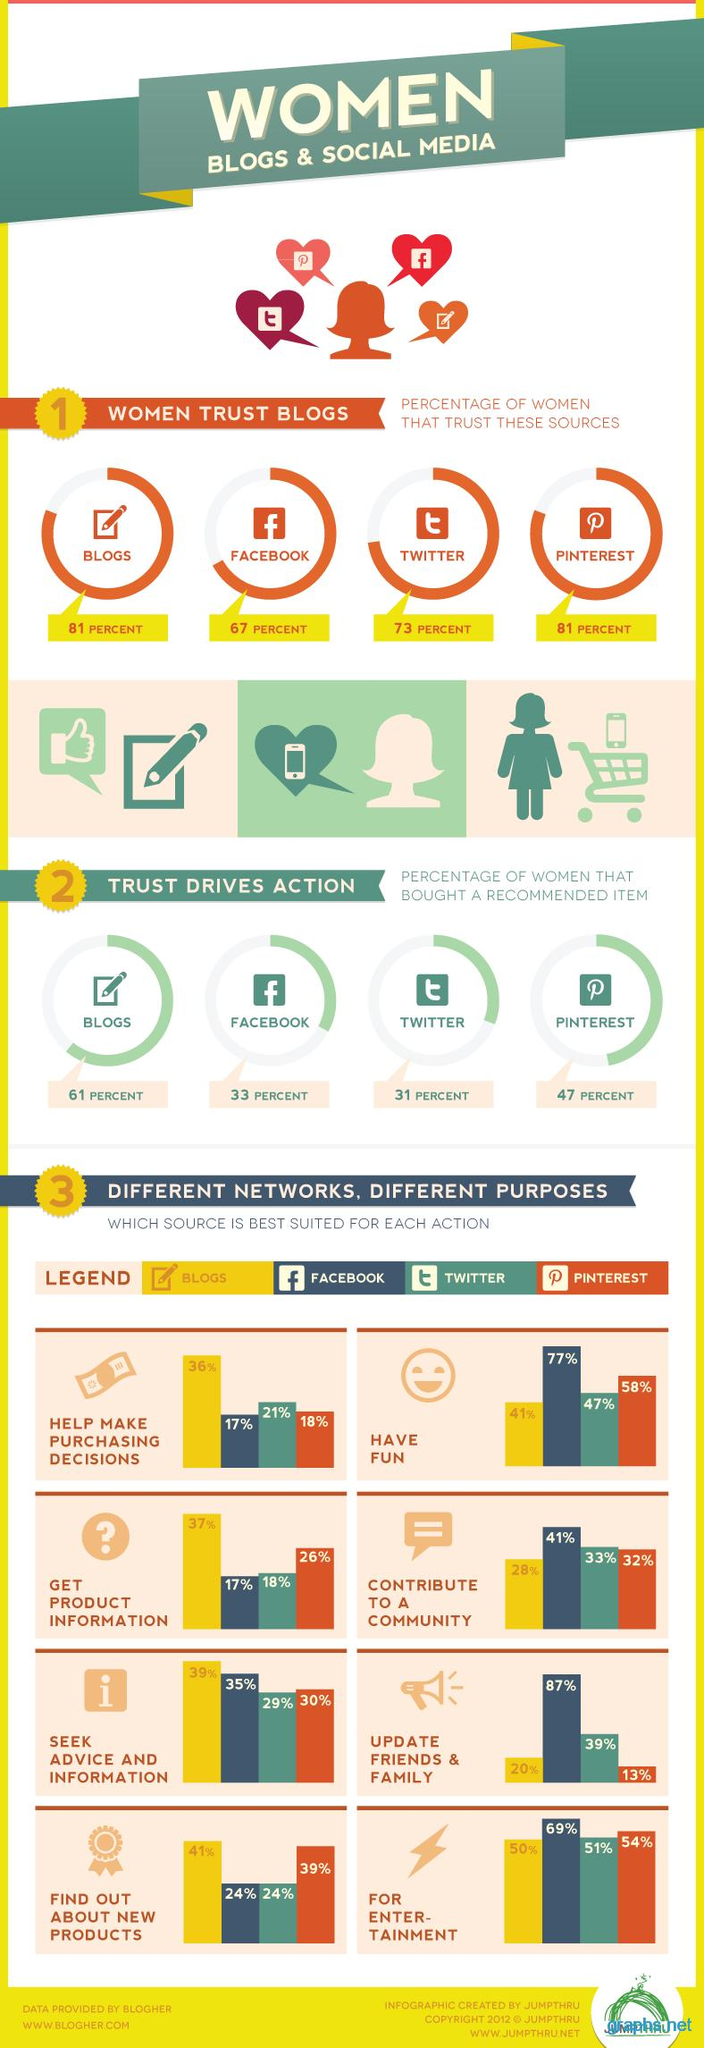Give some essential details in this illustration. Facebook is not trusted by more number of women than Twitter. In fact, Twitter is more trusted by women. According to the source, Facebook was the preferred platform of 77% of women for having fun. According to the given information, Pinterest was the platform that was used by 54% of women for entertainment purposes. According to the information provided, approximately 47% of women made a purchase after being recommended an item on Pinterest. According to a recent study, approximately 33% of women purchased a recommended item on Facebook. 